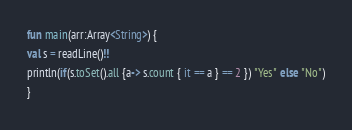Convert code to text. <code><loc_0><loc_0><loc_500><loc_500><_Kotlin_>fun main(arr:Array<String>) {
val s = readLine()!!
println(if(s.toSet().all {a-> s.count { it == a } == 2 }) "Yes" else "No")
}
</code> 